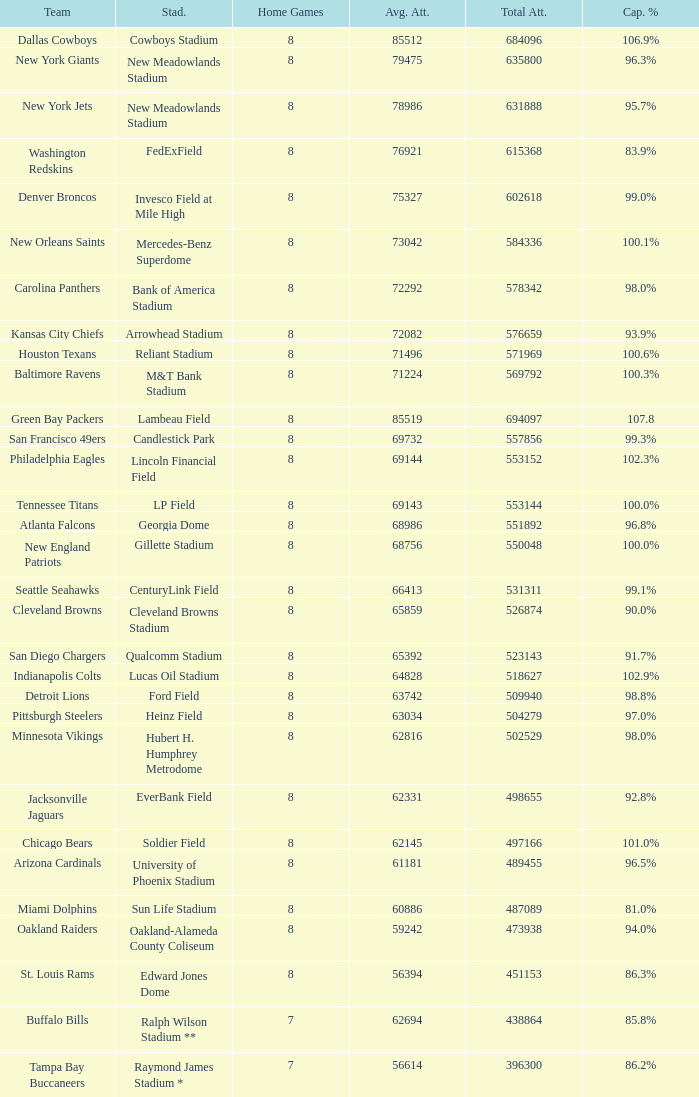What is the capacity percentage when the total attendance is 509940? 98.8%. 